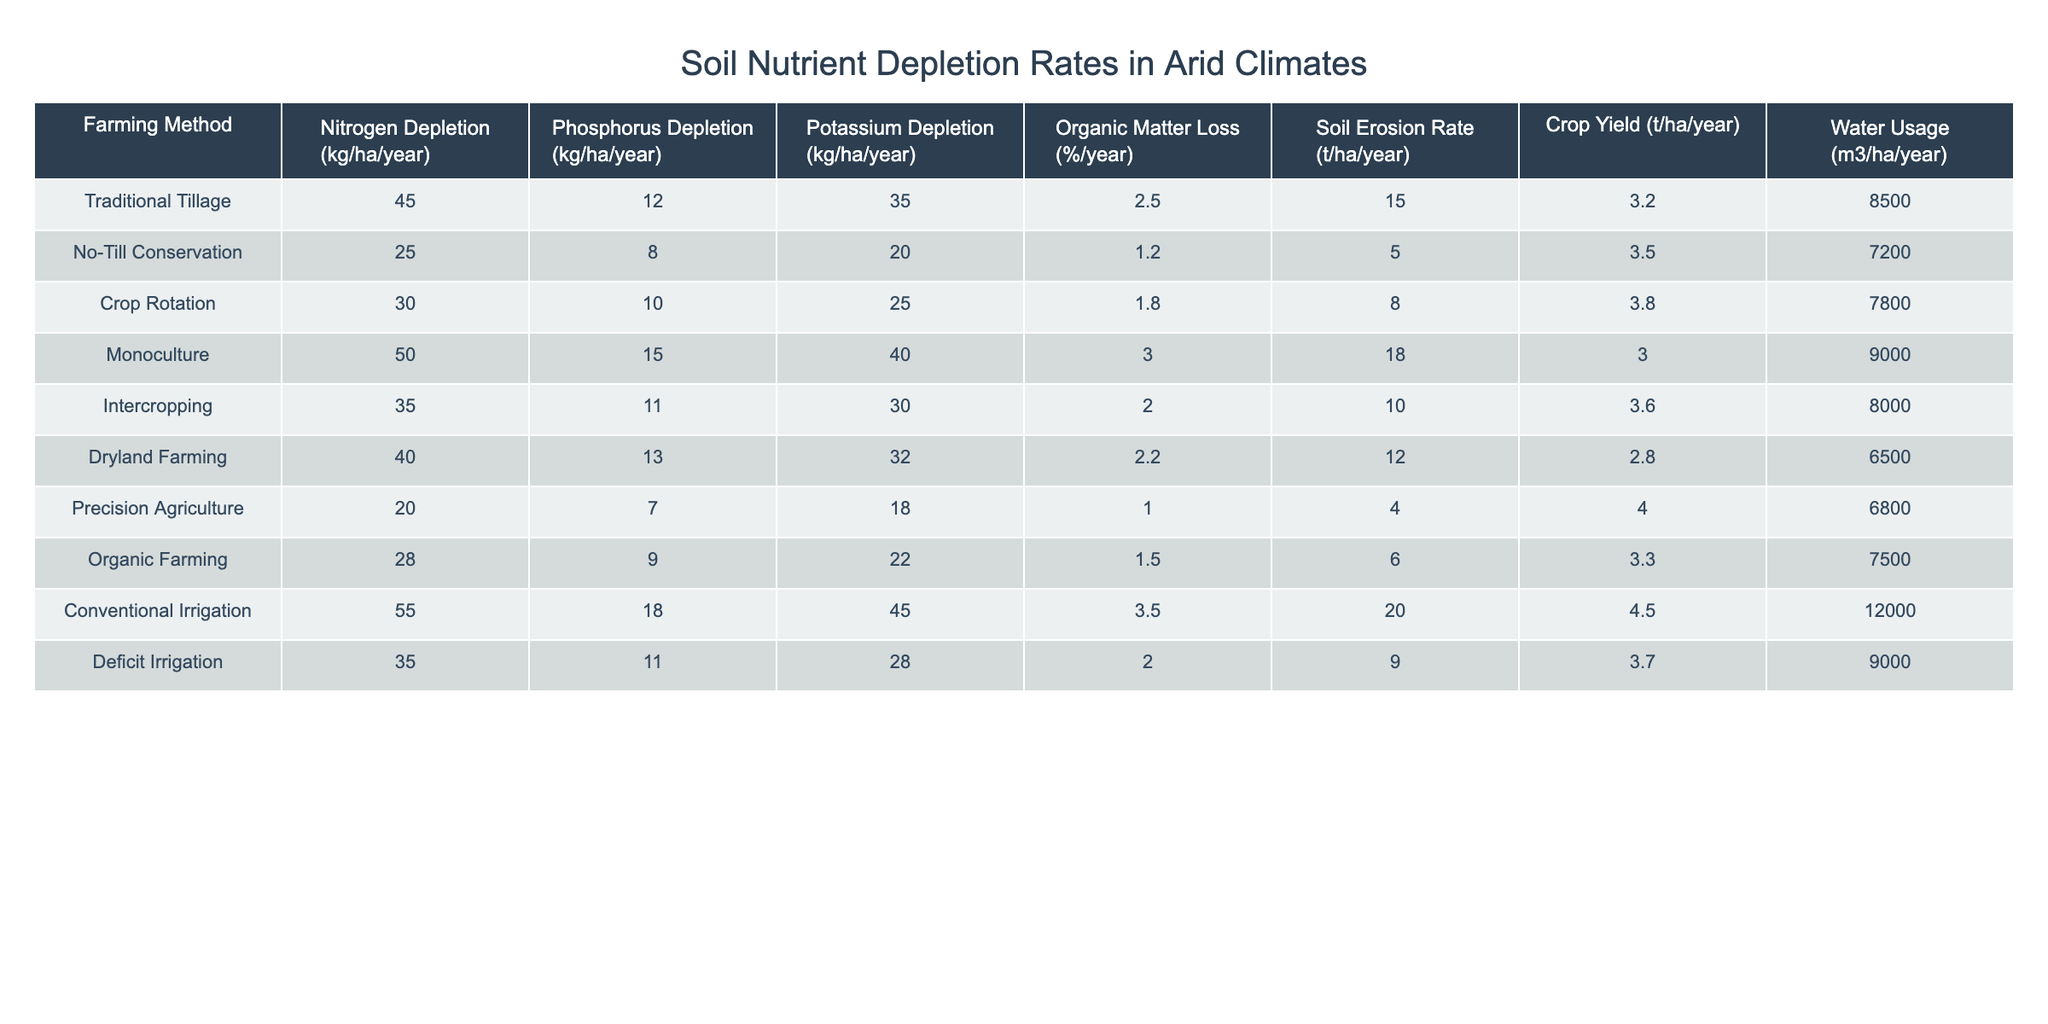What is the nitrogen depletion rate for conventional irrigation? The table shows that the nitrogen depletion rate for conventional irrigation is listed as 55 kg/ha/year.
Answer: 55 kg/ha/year Which farming method results in the highest potassium depletion? By examining the table, it can be seen that conventional irrigation has the highest potassium depletion rate of 45 kg/ha/year compared to other methods.
Answer: Conventional irrigation What is the average organic matter loss for all farming methods listed? To find the average, we sum the organic matter loss percentages: (2.5 + 1.2 + 1.8 + 3.0 + 2.0 + 2.2 + 1.0 + 1.5 + 3.5 + 2.0) = 17.5. There are 10 methods, so the average is 17.5 / 10 = 1.75%.
Answer: 1.75% Is there a farming method that has a phosphorus depletion rate higher than 15 kg/ha/year? Checking the table reveals that conventional irrigation has the highest phosphorus depletion rate at 18 kg/ha/year, which is indeed higher than 15 kg/ha/year.
Answer: Yes Which farming method shows the combination of the lowest soil erosion rate and the highest crop yield? The table indicates that precision agriculture has the lowest soil erosion rate at 4 t/ha/year and a crop yield of 4.0 t/ha/year, which is higher than that of other methods with a similar erosion rate.
Answer: Precision agriculture What is the difference in crop yield between monoculture and no-till conservation? The crop yield for monoculture is 3.0 t/ha/year and for no-till conservation it is 3.5 t/ha/year. The difference is calculated as 3.5 - 3.0 = 0.5 t/ha/year.
Answer: 0.5 t/ha/year If we combine the phosphorus depletion rates of traditional tillage and organic farming, what total do we reach? Adding the phosphorus depletion rates of traditional tillage (12 kg/ha/year) and organic farming (9 kg/ha/year) gives us a total of 12 + 9 = 21 kg/ha/year.
Answer: 21 kg/ha/year Which method has the highest water usage, and how much is that? The water usage for conventional irrigation is the highest at 12000 m3/ha/year, as indicated in the table.
Answer: 12000 m3/ha/year Does intercropping result in more potassium depletion than dryland farming? Intercropping shows a potassium depletion rate of 30 kg/ha/year while dryland farming has 32 kg/ha/year, meaning intercropping does not exceed dryland farming in potassium depletion.
Answer: No What farming method has both the lowest nitrogen depletion and organic matter loss percentage? By analyzing the table, precision agriculture has the lowest nitrogen depletion at 20 kg/ha/year and an organic matter loss of 1.0%/year, which is lower than all other farming methods.
Answer: Precision agriculture 